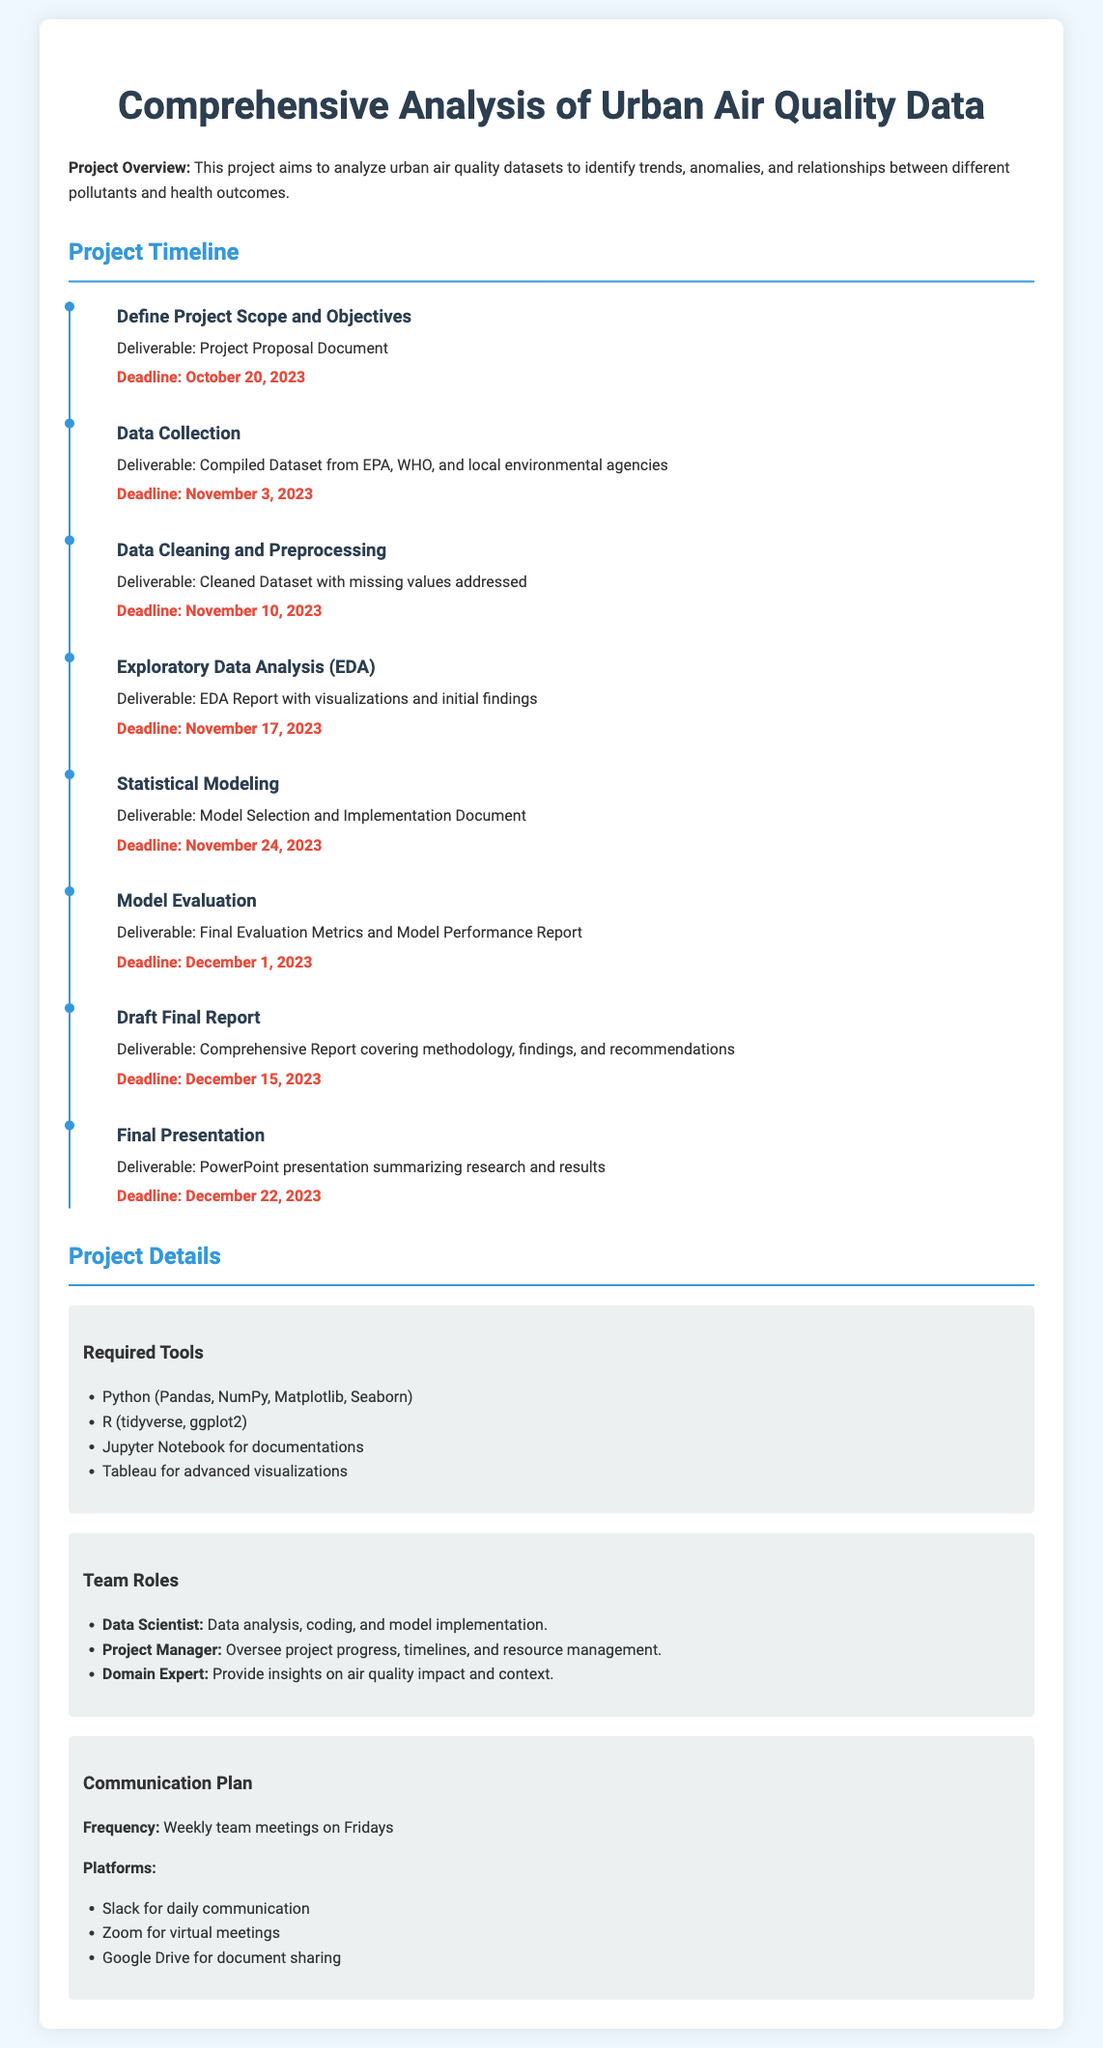What is the title of the project? The title of the project is prominently displayed at the top of the document.
Answer: Comprehensive Analysis of Urban Air Quality Data When is the deadline for data collection? The deadline for data collection is specifically mentioned in the Project Timeline section.
Answer: November 3, 2023 What is the deliverable for the exploratory data analysis phase? The deliverable is stated alongside the milestone in the timeline.
Answer: EDA Report with visualizations and initial findings Who is responsible for overseeing project progress? The role responsible for overseeing project progress is indicated in the Team Roles section.
Answer: Project Manager What tool is mentioned for advanced visualizations? The tools required for the project include multiple software, one of which is specifically listed for advanced visualizations.
Answer: Tableau How many weeks are there between the start of data cleaning and the final presentation? The timeline allows for calculation based on the specified deadlines for both milestones.
Answer: 6 weeks What is the date for the final evaluation metrics submission? The final evaluation metrics submission date is provided under the Project Timeline section.
Answer: December 1, 2023 What communication platform is used for daily communication? The communication plan outlines the platforms used for various types of communication.
Answer: Slack What document is to be submitted at the end of the project? The comprehensive report document is specifically mentioned in the timeline as a deliverable.
Answer: Comprehensive Report covering methodology, findings, and recommendations 